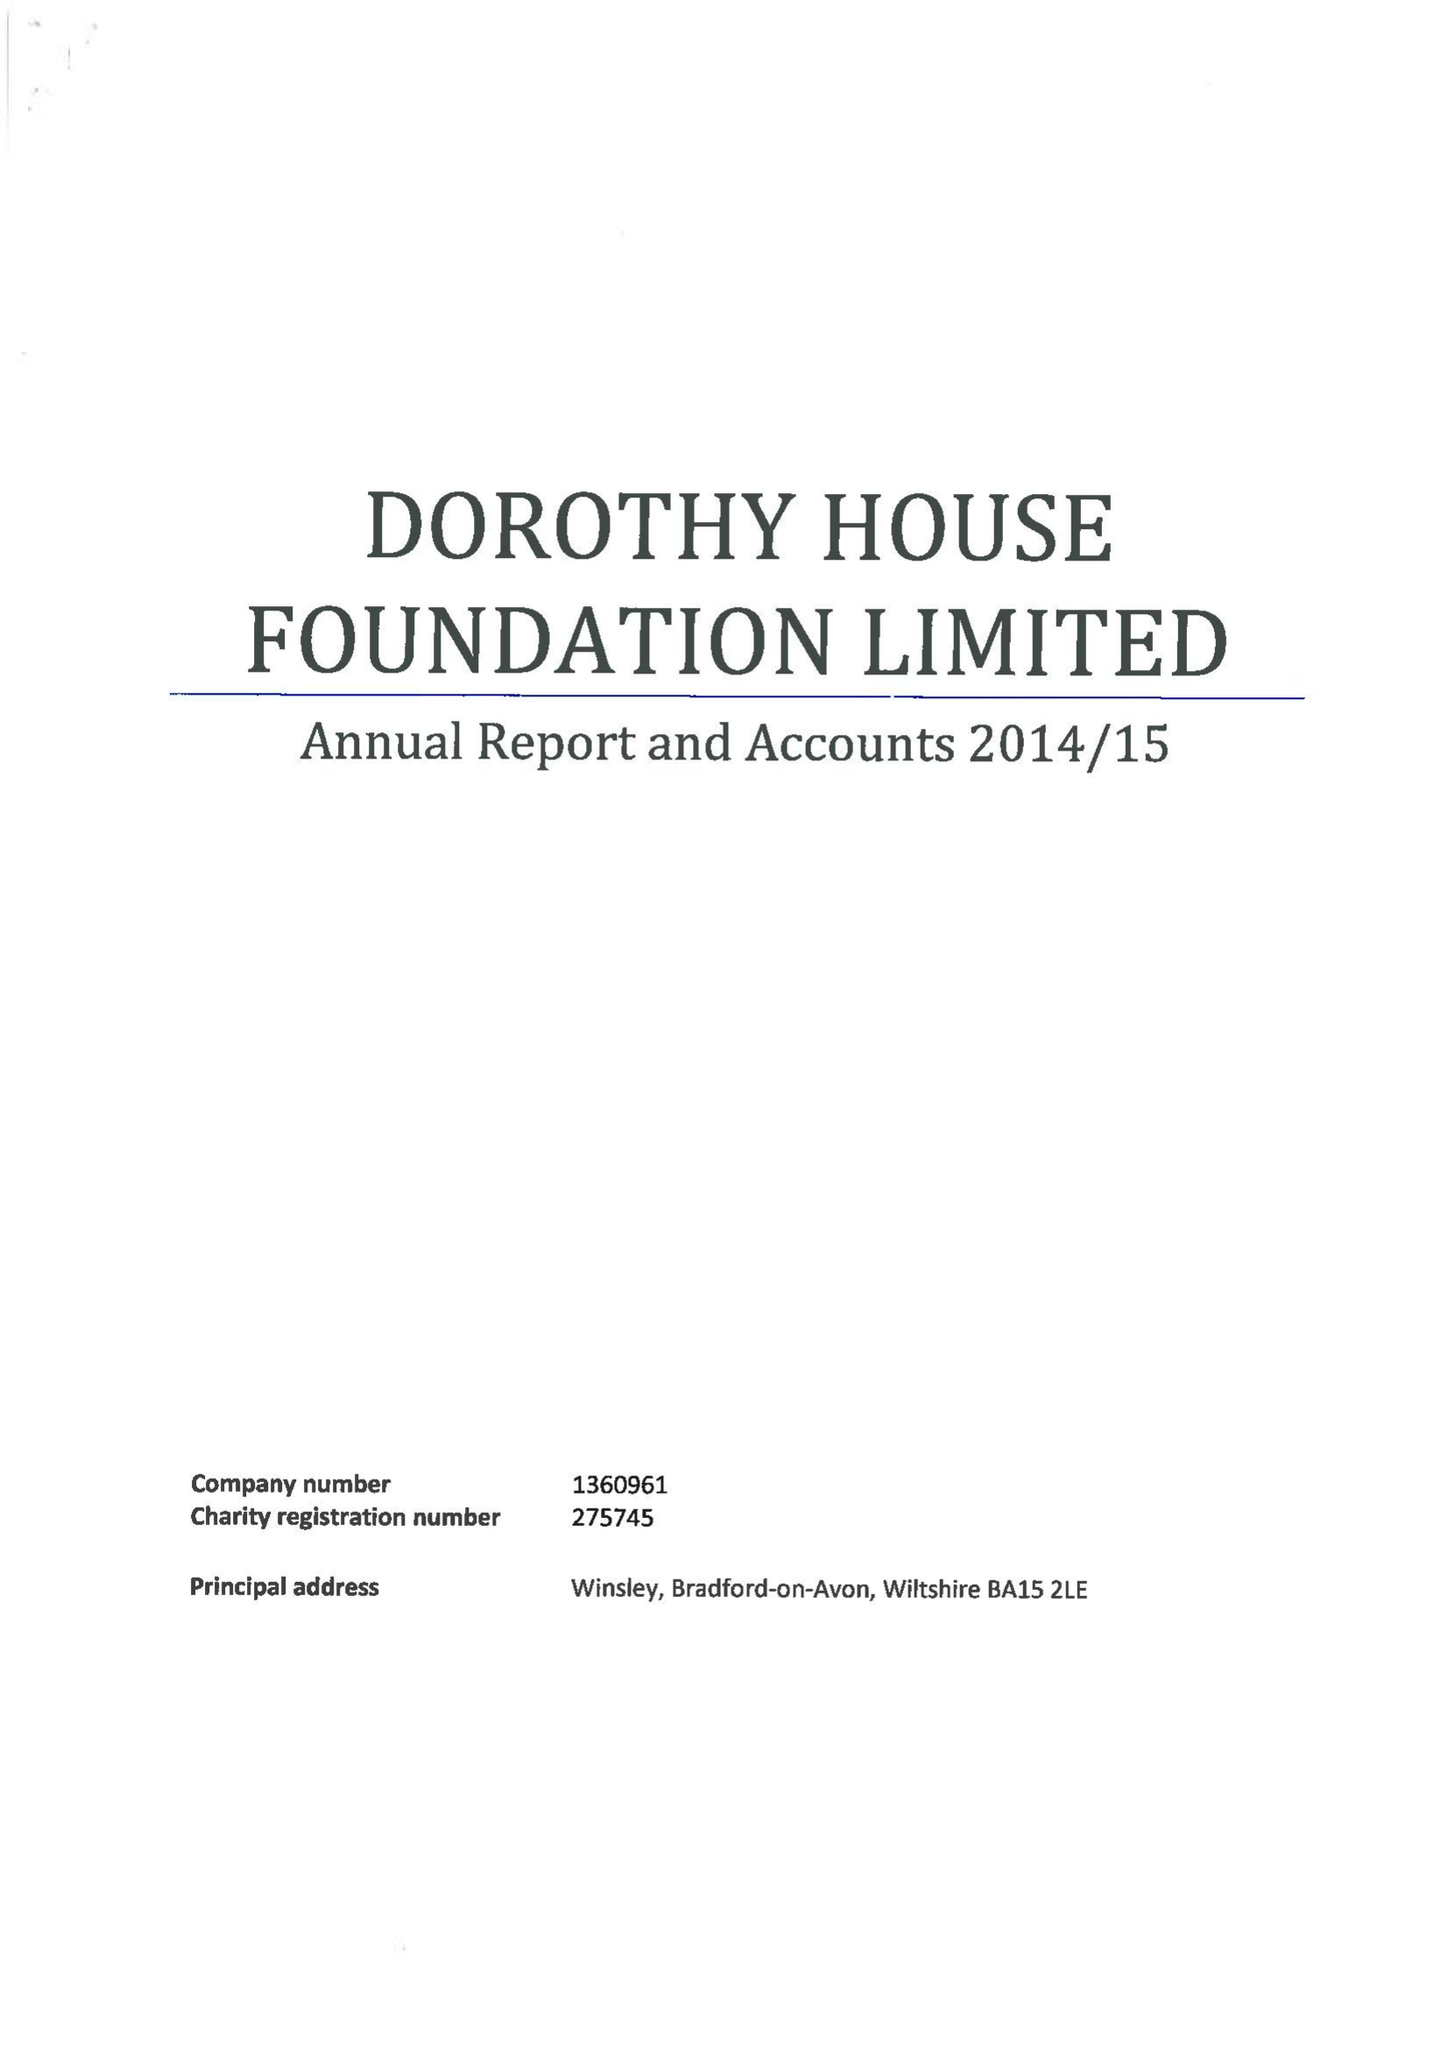What is the value for the spending_annually_in_british_pounds?
Answer the question using a single word or phrase. 11535887.00 